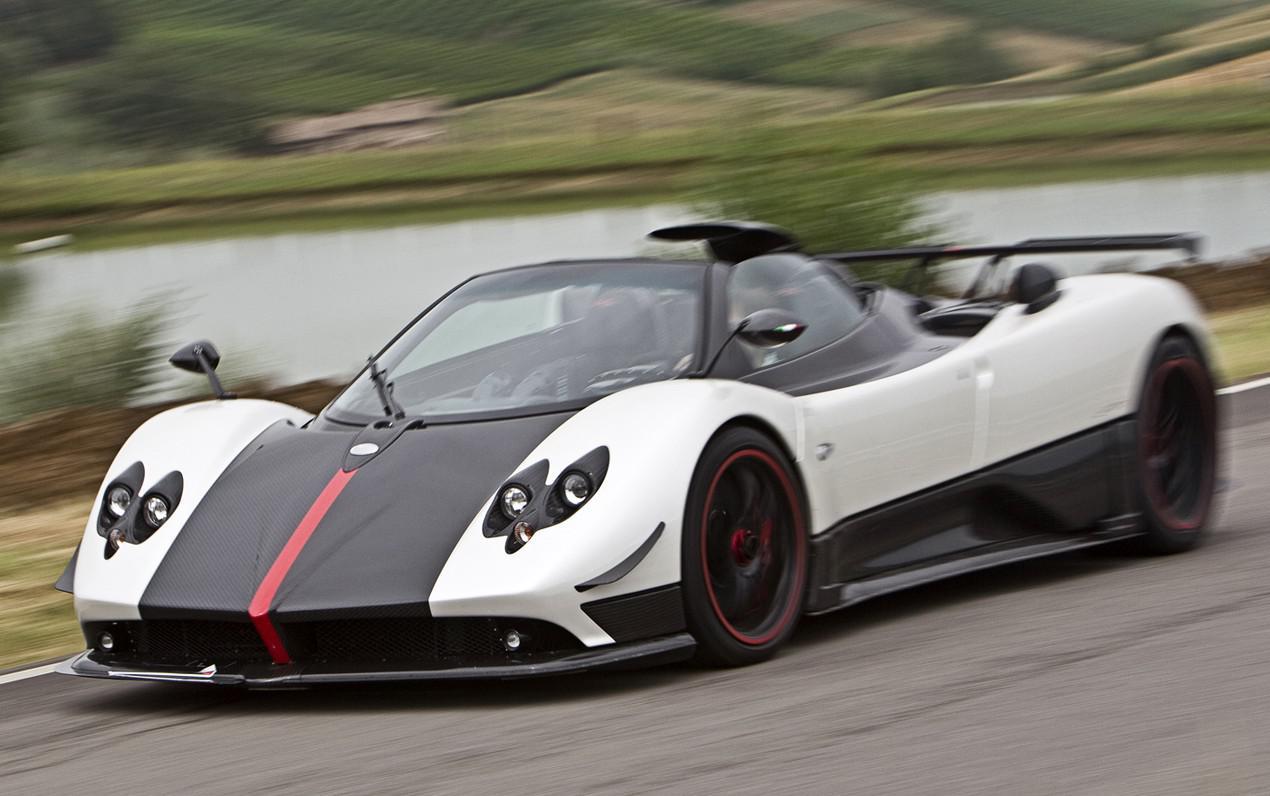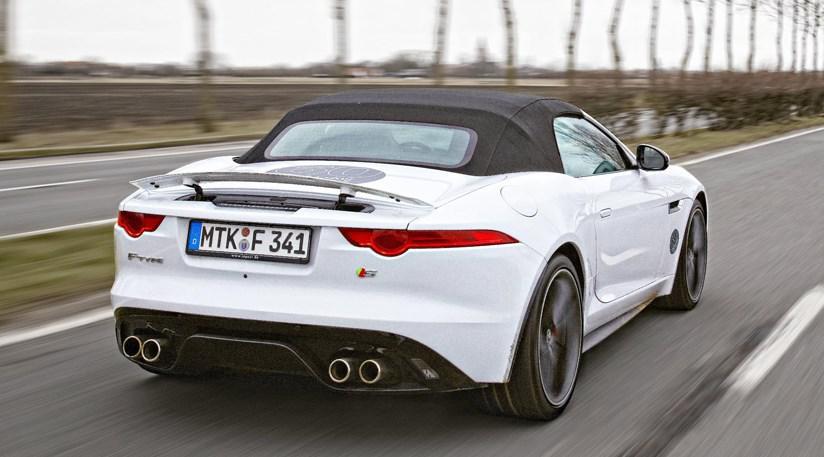The first image is the image on the left, the second image is the image on the right. Assess this claim about the two images: "An image shows a bright blue convertible with its top down.". Correct or not? Answer yes or no. No. The first image is the image on the left, the second image is the image on the right. For the images shown, is this caption "There is a blue car in the left image." true? Answer yes or no. No. 